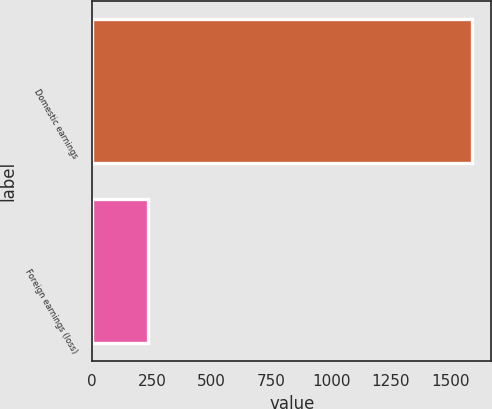Convert chart to OTSL. <chart><loc_0><loc_0><loc_500><loc_500><bar_chart><fcel>Domestic earnings<fcel>Foreign earnings (loss)<nl><fcel>1590<fcel>234<nl></chart> 